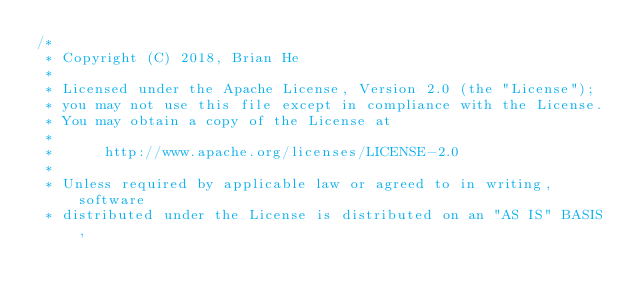Convert code to text. <code><loc_0><loc_0><loc_500><loc_500><_Java_>/*
 * Copyright (C) 2018, Brian He
 *
 * Licensed under the Apache License, Version 2.0 (the "License");
 * you may not use this file except in compliance with the License.
 * You may obtain a copy of the License at
 *
 *      http://www.apache.org/licenses/LICENSE-2.0
 *
 * Unless required by applicable law or agreed to in writing, software
 * distributed under the License is distributed on an "AS IS" BASIS,</code> 